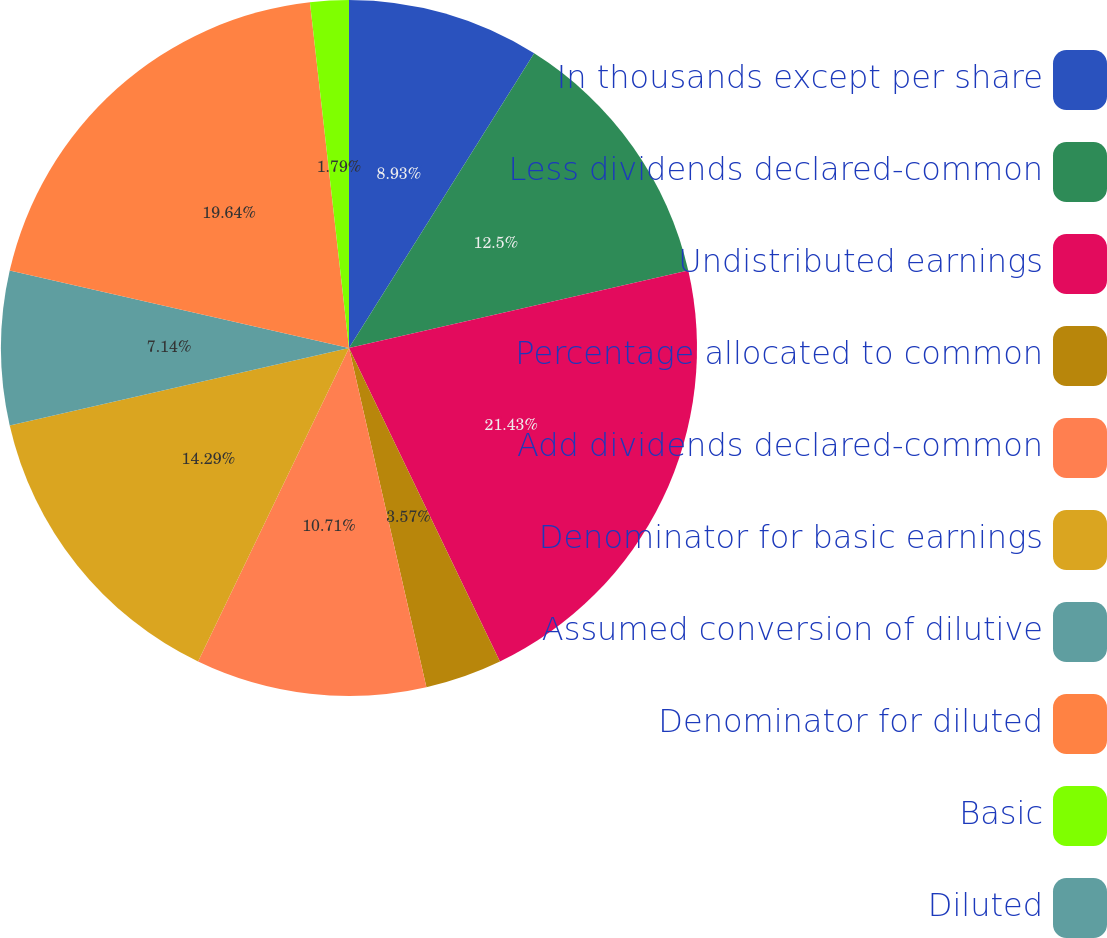Convert chart to OTSL. <chart><loc_0><loc_0><loc_500><loc_500><pie_chart><fcel>In thousands except per share<fcel>Less dividends declared-common<fcel>Undistributed earnings<fcel>Percentage allocated to common<fcel>Add dividends declared-common<fcel>Denominator for basic earnings<fcel>Assumed conversion of dilutive<fcel>Denominator for diluted<fcel>Basic<fcel>Diluted<nl><fcel>8.93%<fcel>12.5%<fcel>21.43%<fcel>3.57%<fcel>10.71%<fcel>14.29%<fcel>7.14%<fcel>19.64%<fcel>1.79%<fcel>0.0%<nl></chart> 